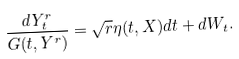Convert formula to latex. <formula><loc_0><loc_0><loc_500><loc_500>\frac { d Y ^ { r } _ { t } } { G ( t , Y ^ { r } ) } = \sqrt { r } \eta ( t , X ) d t + d W _ { t } .</formula> 